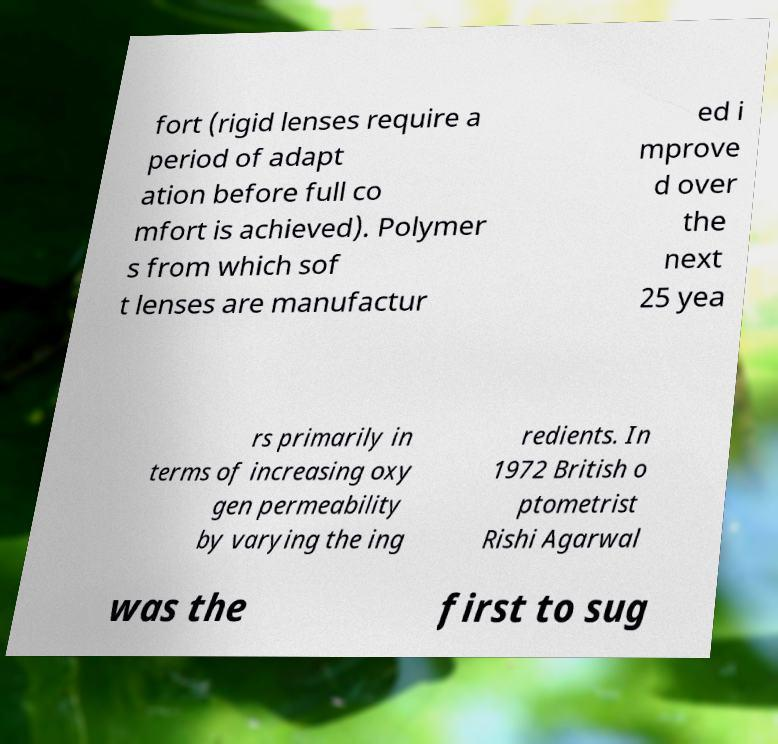Can you accurately transcribe the text from the provided image for me? fort (rigid lenses require a period of adapt ation before full co mfort is achieved). Polymer s from which sof t lenses are manufactur ed i mprove d over the next 25 yea rs primarily in terms of increasing oxy gen permeability by varying the ing redients. In 1972 British o ptometrist Rishi Agarwal was the first to sug 